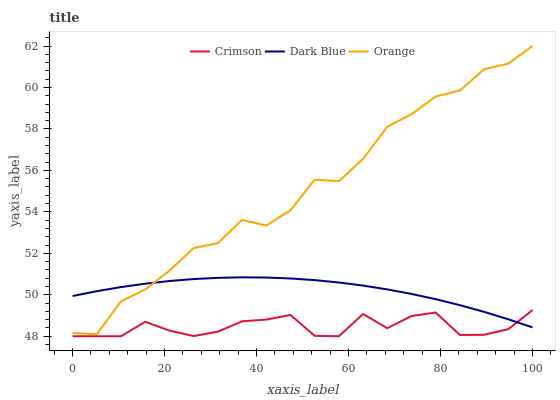Does Crimson have the minimum area under the curve?
Answer yes or no. Yes. Does Orange have the maximum area under the curve?
Answer yes or no. Yes. Does Dark Blue have the minimum area under the curve?
Answer yes or no. No. Does Dark Blue have the maximum area under the curve?
Answer yes or no. No. Is Dark Blue the smoothest?
Answer yes or no. Yes. Is Orange the roughest?
Answer yes or no. Yes. Is Orange the smoothest?
Answer yes or no. No. Is Dark Blue the roughest?
Answer yes or no. No. Does Crimson have the lowest value?
Answer yes or no. Yes. Does Orange have the lowest value?
Answer yes or no. No. Does Orange have the highest value?
Answer yes or no. Yes. Does Dark Blue have the highest value?
Answer yes or no. No. Is Crimson less than Orange?
Answer yes or no. Yes. Is Orange greater than Crimson?
Answer yes or no. Yes. Does Orange intersect Dark Blue?
Answer yes or no. Yes. Is Orange less than Dark Blue?
Answer yes or no. No. Is Orange greater than Dark Blue?
Answer yes or no. No. Does Crimson intersect Orange?
Answer yes or no. No. 